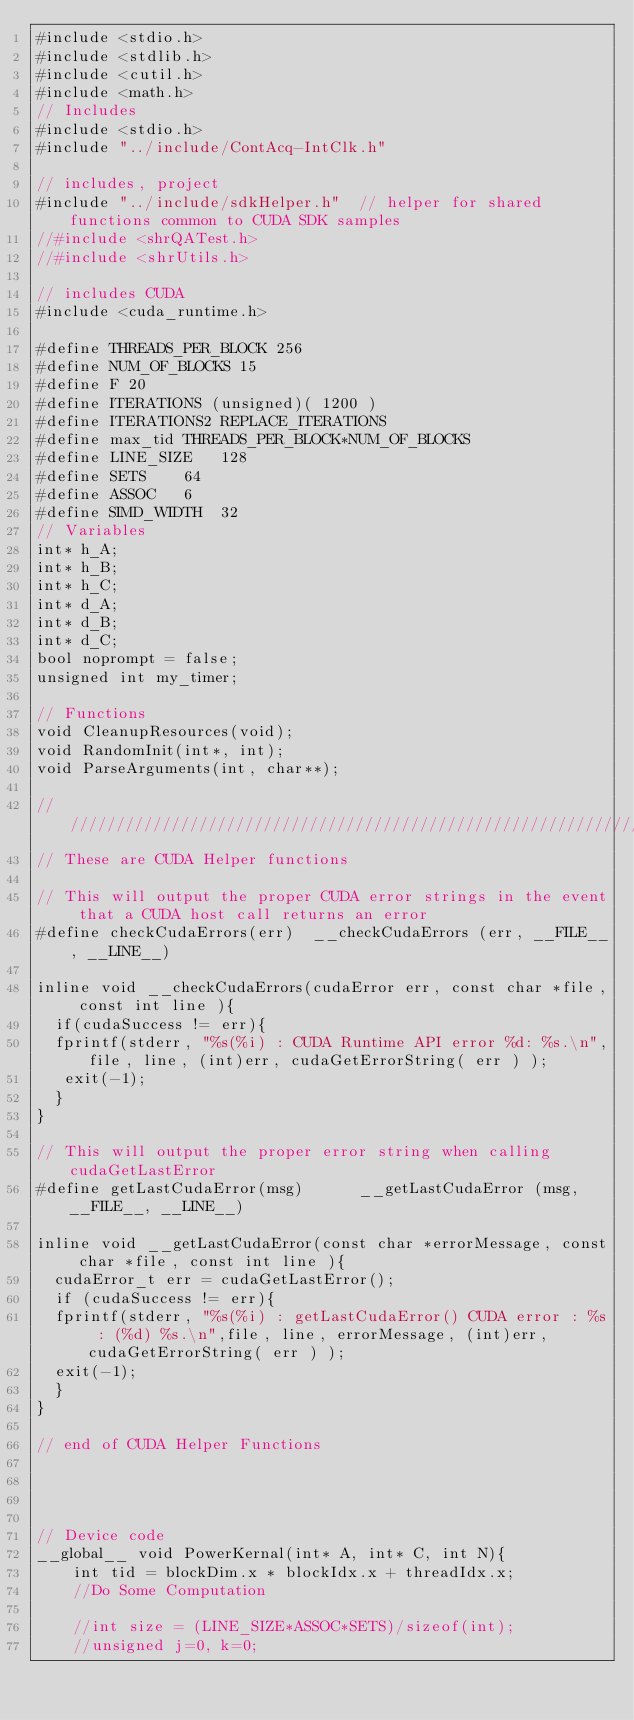<code> <loc_0><loc_0><loc_500><loc_500><_Cuda_>#include <stdio.h>
#include <stdlib.h>
#include <cutil.h>
#include <math.h>
// Includes
#include <stdio.h>
#include "../include/ContAcq-IntClk.h"

// includes, project
#include "../include/sdkHelper.h"  // helper for shared functions common to CUDA SDK samples
//#include <shrQATest.h>
//#include <shrUtils.h>

// includes CUDA
#include <cuda_runtime.h>

#define THREADS_PER_BLOCK 256
#define NUM_OF_BLOCKS 15
#define F 20
#define ITERATIONS (unsigned)( 1200 )
#define ITERATIONS2 REPLACE_ITERATIONS
#define max_tid THREADS_PER_BLOCK*NUM_OF_BLOCKS
#define LINE_SIZE 	128
#define SETS		64
#define ASSOC		6
#define SIMD_WIDTH	32
// Variables
int* h_A;
int* h_B;
int* h_C;
int* d_A;
int* d_B;
int* d_C;
bool noprompt = false;
unsigned int my_timer;

// Functions
void CleanupResources(void);
void RandomInit(int*, int);
void ParseArguments(int, char**);

////////////////////////////////////////////////////////////////////////////////
// These are CUDA Helper functions

// This will output the proper CUDA error strings in the event that a CUDA host call returns an error
#define checkCudaErrors(err)  __checkCudaErrors (err, __FILE__, __LINE__)

inline void __checkCudaErrors(cudaError err, const char *file, const int line ){
  if(cudaSuccess != err){
	fprintf(stderr, "%s(%i) : CUDA Runtime API error %d: %s.\n",file, line, (int)err, cudaGetErrorString( err ) );
	 exit(-1);
  }
}

// This will output the proper error string when calling cudaGetLastError
#define getLastCudaError(msg)      __getLastCudaError (msg, __FILE__, __LINE__)

inline void __getLastCudaError(const char *errorMessage, const char *file, const int line ){
  cudaError_t err = cudaGetLastError();
  if (cudaSuccess != err){
	fprintf(stderr, "%s(%i) : getLastCudaError() CUDA error : %s : (%d) %s.\n",file, line, errorMessage, (int)err, cudaGetErrorString( err ) );
	exit(-1);
  }
}

// end of CUDA Helper Functions




// Device code
__global__ void PowerKernal(int* A, int* C, int N){
    int tid = blockDim.x * blockIdx.x + threadIdx.x;
    //Do Some Computation

    //int size = (LINE_SIZE*ASSOC*SETS)/sizeof(int);
    //unsigned j=0, k=0;</code> 